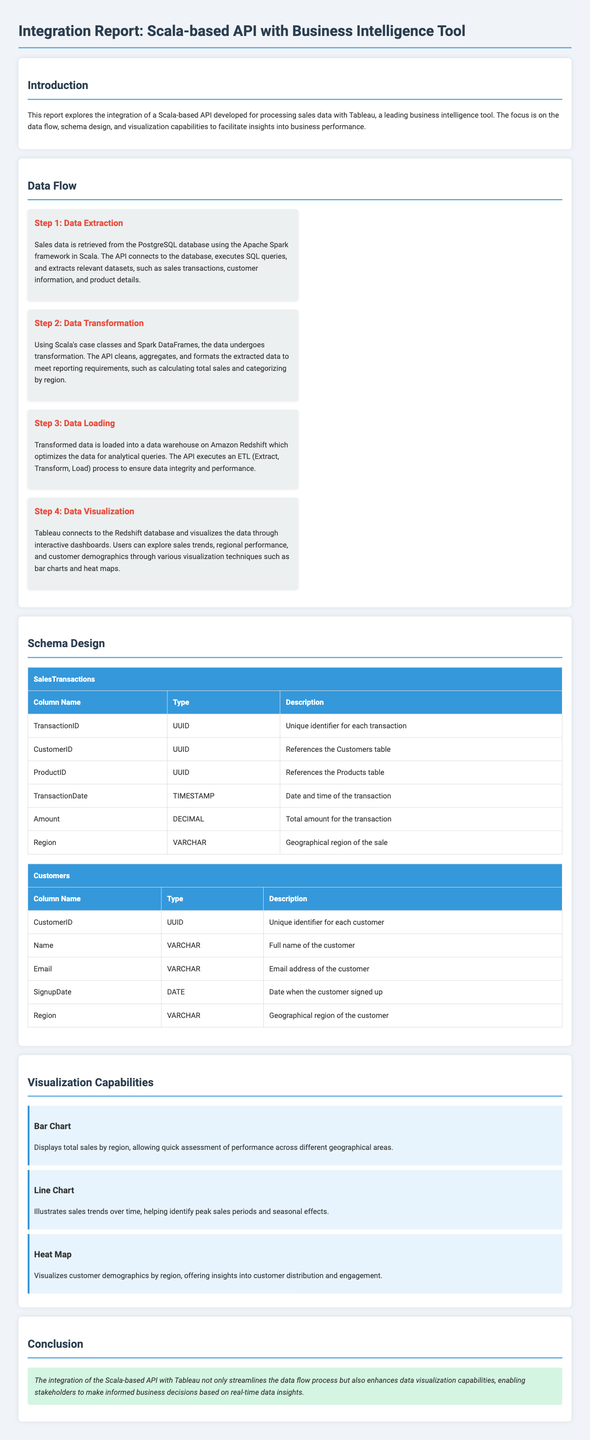What is the primary purpose of this report? The report explores the integration of a Scala-based API with Tableau focusing on data flow, schema design, and visualization capabilities.
Answer: Integration of a Scala-based API with Tableau What is the first step in the data flow? The first step is to retrieve sales data from the PostgreSQL database using the Apache Spark framework.
Answer: Data Extraction What type of data transformation is performed in Step 2? The API cleans, aggregates, and formats the data to meet reporting requirements such as calculating total sales.
Answer: Cleaning and aggregating Which database is used for loading transformed data? The transformed data is loaded into Amazon Redshift.
Answer: Amazon Redshift What is the unique identifier for each transaction? The unique identifier is the TransactionID which is of type UUID.
Answer: TransactionID What visualization technique is used to display total sales by region? A bar chart is used to display total sales by region.
Answer: Bar Chart What column in the Customers table contains the full name of the customer? The column containing the full name of the customer is 'Name'.
Answer: Name What does the heat map visualize in the context of the report? The heat map visualizes customer demographics by region.
Answer: Customer demographics by region What is stated in the conclusion about the integration? The integration enhances data visualization capabilities, enabling informed business decisions.
Answer: Enhances data visualization capabilities 